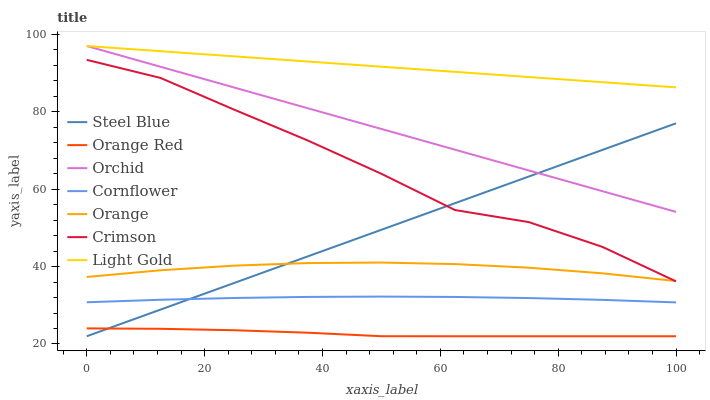Does Orange Red have the minimum area under the curve?
Answer yes or no. Yes. Does Light Gold have the maximum area under the curve?
Answer yes or no. Yes. Does Steel Blue have the minimum area under the curve?
Answer yes or no. No. Does Steel Blue have the maximum area under the curve?
Answer yes or no. No. Is Steel Blue the smoothest?
Answer yes or no. Yes. Is Crimson the roughest?
Answer yes or no. Yes. Is Crimson the smoothest?
Answer yes or no. No. Is Steel Blue the roughest?
Answer yes or no. No. Does Steel Blue have the lowest value?
Answer yes or no. Yes. Does Crimson have the lowest value?
Answer yes or no. No. Does Orchid have the highest value?
Answer yes or no. Yes. Does Steel Blue have the highest value?
Answer yes or no. No. Is Orange Red less than Orange?
Answer yes or no. Yes. Is Orchid greater than Crimson?
Answer yes or no. Yes. Does Light Gold intersect Orchid?
Answer yes or no. Yes. Is Light Gold less than Orchid?
Answer yes or no. No. Is Light Gold greater than Orchid?
Answer yes or no. No. Does Orange Red intersect Orange?
Answer yes or no. No. 